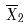<formula> <loc_0><loc_0><loc_500><loc_500>\overline { X } _ { 2 }</formula> 